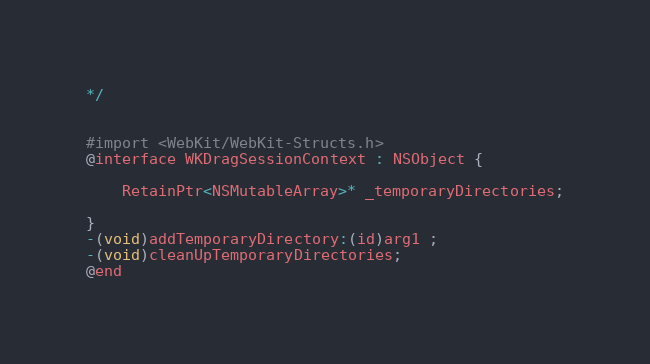Convert code to text. <code><loc_0><loc_0><loc_500><loc_500><_C_>*/


#import <WebKit/WebKit-Structs.h>
@interface WKDragSessionContext : NSObject {

	RetainPtr<NSMutableArray>* _temporaryDirectories;

}
-(void)addTemporaryDirectory:(id)arg1 ;
-(void)cleanUpTemporaryDirectories;
@end

</code> 